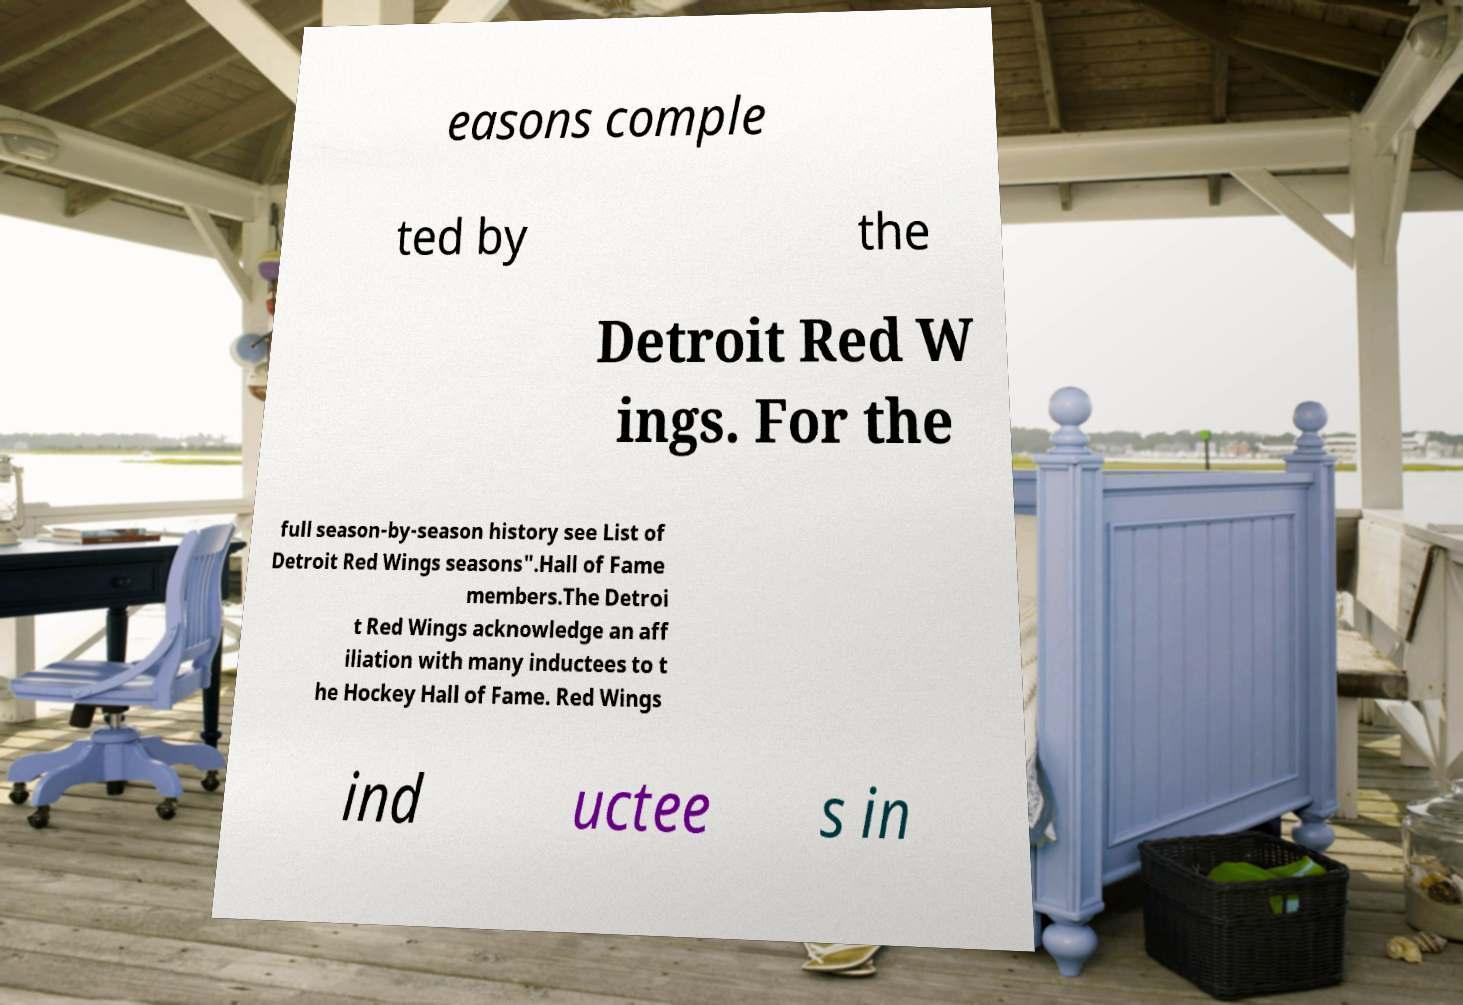I need the written content from this picture converted into text. Can you do that? easons comple ted by the Detroit Red W ings. For the full season-by-season history see List of Detroit Red Wings seasons".Hall of Fame members.The Detroi t Red Wings acknowledge an aff iliation with many inductees to t he Hockey Hall of Fame. Red Wings ind uctee s in 